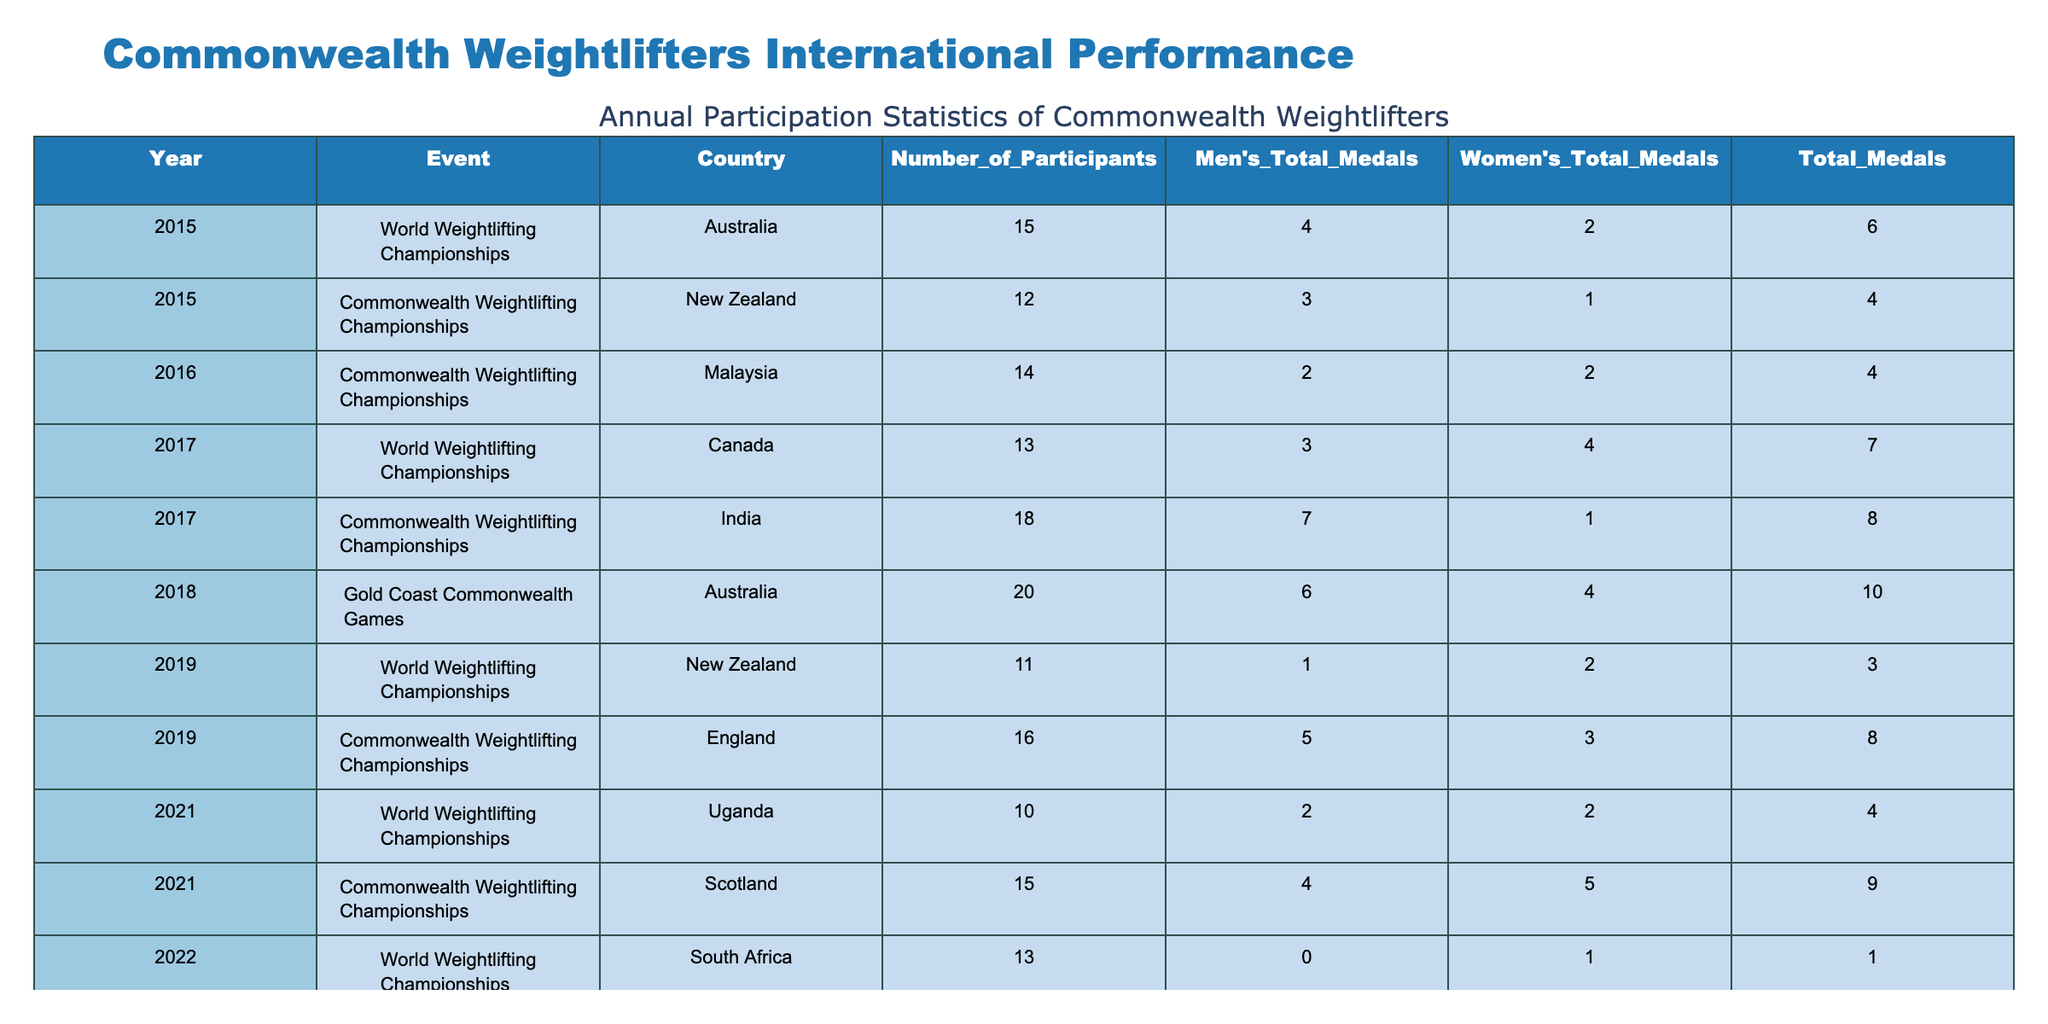What was the total number of participants from Australia in 2015? In 2015, Australia participated in the World Weightlifting Championships with 15 athletes. Therefore, the total number of participants from Australia is 15.
Answer: 15 Which event had the highest total number of medals won in 2018? In 2018, the Gold Coast Commonwealth Games resulted in a total of 10 medals for Australia, which is higher than any other event listed for that year.
Answer: 10 Which country won the most total medals in 2017? In 2017, India at the Commonwealth Weightlifting Championships won 8 medals, which is higher than any other country that year.
Answer: India What was the difference in the number of women's total medals between the 2017 Commonwealth Weightlifting Championships and the 2023 Commonwealth Games? In 2017, the women's total medals for India were 1, and in 2023, India's women's total medals were 4. Therefore, the difference is 4 - 1 = 3.
Answer: 3 Was there any event in 2022 where any country won zero men's total medals? Yes, in the World Weightlifting Championships in 2022, South Africa won 0 men's total medals.
Answer: Yes What is the average number of total medals won by New Zealand in the provided events? New Zealand won a total of 6 medals across two events: 4 in 2015 at the Commonwealth Championships and 3 in 2019 at the World Championships. The sum is 4 + 3 = 7, and since there are 2 events, the average is 7/2 = 3.5.
Answer: 3.5 Which country had the highest number of participants in 2023? In 2023, India had the highest number of participants, with 22 at the Commonwealth Games, which is more than any other country that year.
Answer: India How many total medals did Malaysia win in 2022? In 2022, Malaysia won a total of 9 medals at the Commonwealth Weightlifting Championships, which includes both men's and women's medals.
Answer: 9 In which year did Australia achieve a higher total medal count than New Zealand? In 2015, Australia achieved a total of 6 medals while New Zealand had 4 medals in the Commonwealth Weightlifting Championships. Therefore, 2015 is the year when Australia surpassed New Zealand in total medal count.
Answer: 2015 